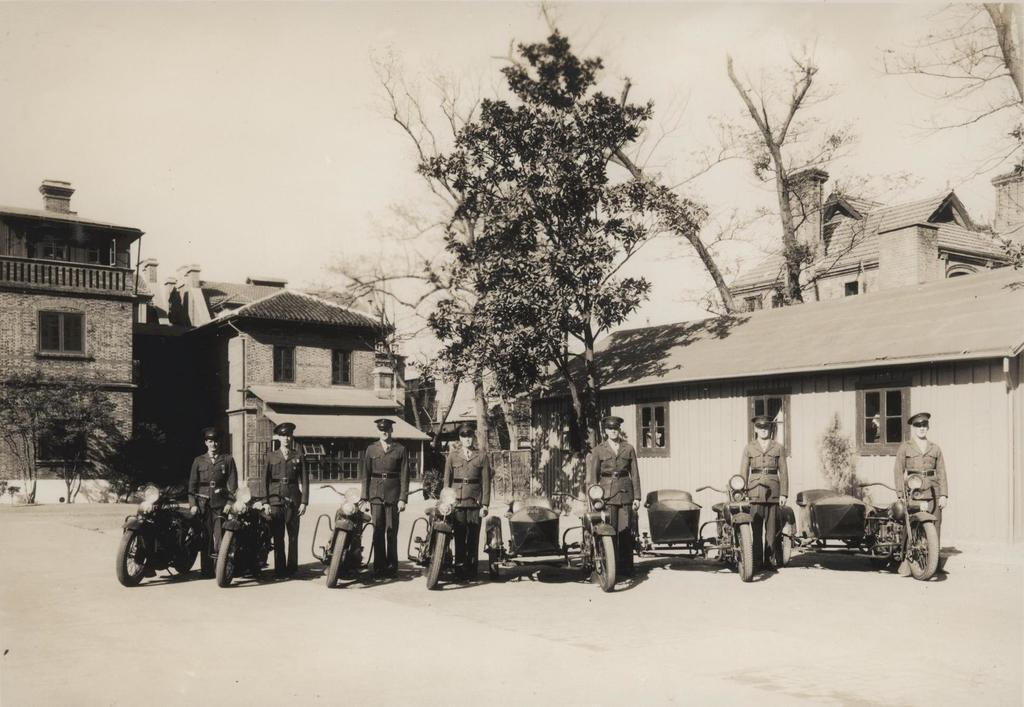What type of image is this? The image is an old black and white picture. What can be seen in the foreground of the image? There are groups of people standing on the path. What else is present in the image besides people? There are vehicles, trees, houses, and the sky visible in the background. What color scarf is the person on the stage wearing in the image? There is no stage or person wearing a scarf present in the image. 